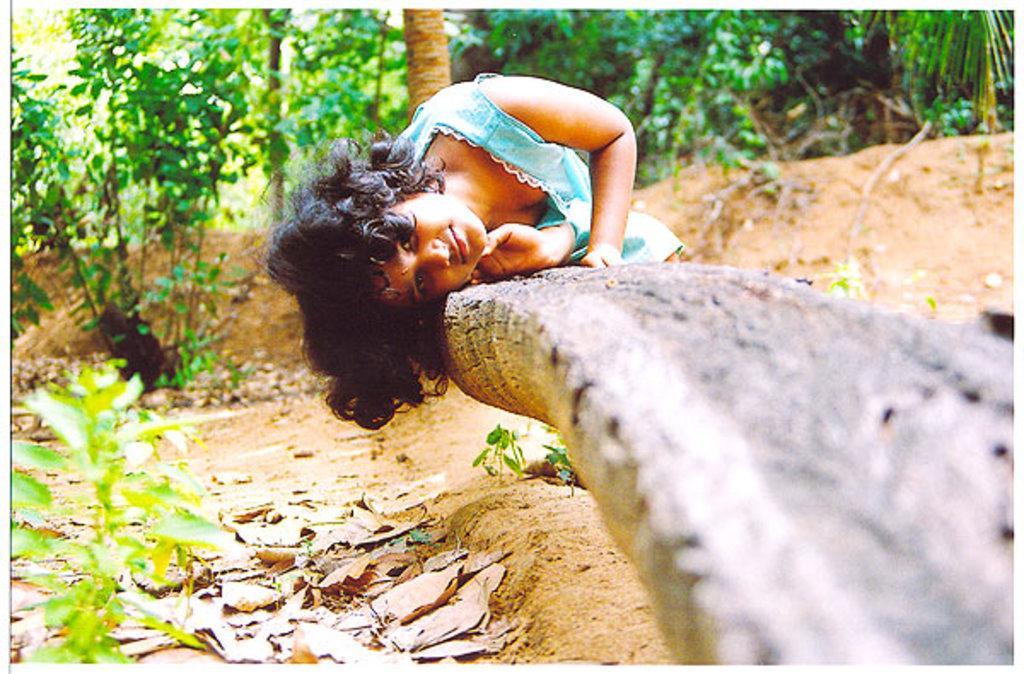Can you describe this image briefly? In this image there is a girl lying on the wooden trunk. On the left side of the image there is a plant. In the background of the image there are trees. 